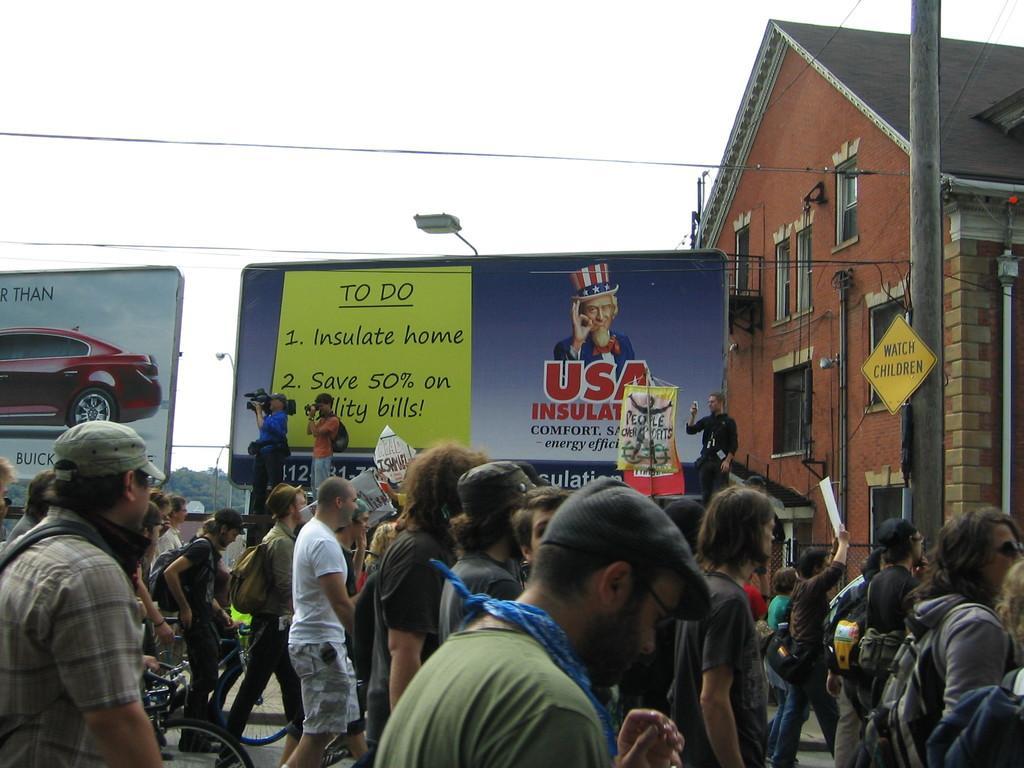Please provide a concise description of this image. To the bottom of the image there are few people on the road. And also there are few people with the bicycles. Behind them there are two posters. In front of the poster there are two men with video camera is standing. And above the poster there is a light. To the right corner of the image there is a pole with board and building with wall, window, roof and pipes. And to the top of the image there is a sky and also there are wires. 